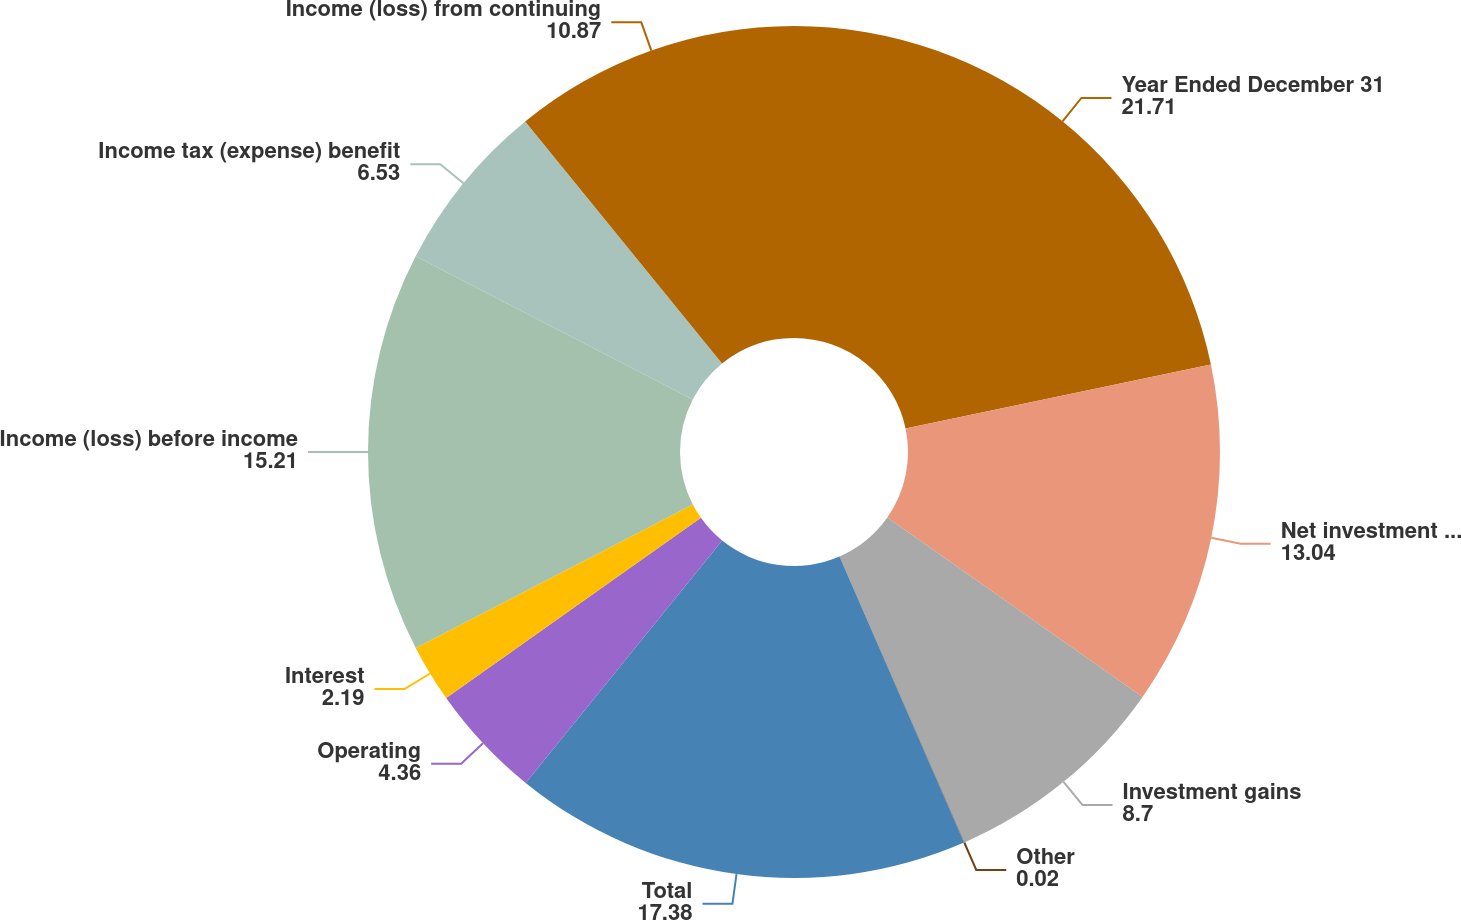<chart> <loc_0><loc_0><loc_500><loc_500><pie_chart><fcel>Year Ended December 31<fcel>Net investment income (loss)<fcel>Investment gains<fcel>Other<fcel>Total<fcel>Operating<fcel>Interest<fcel>Income (loss) before income<fcel>Income tax (expense) benefit<fcel>Income (loss) from continuing<nl><fcel>21.71%<fcel>13.04%<fcel>8.7%<fcel>0.02%<fcel>17.38%<fcel>4.36%<fcel>2.19%<fcel>15.21%<fcel>6.53%<fcel>10.87%<nl></chart> 